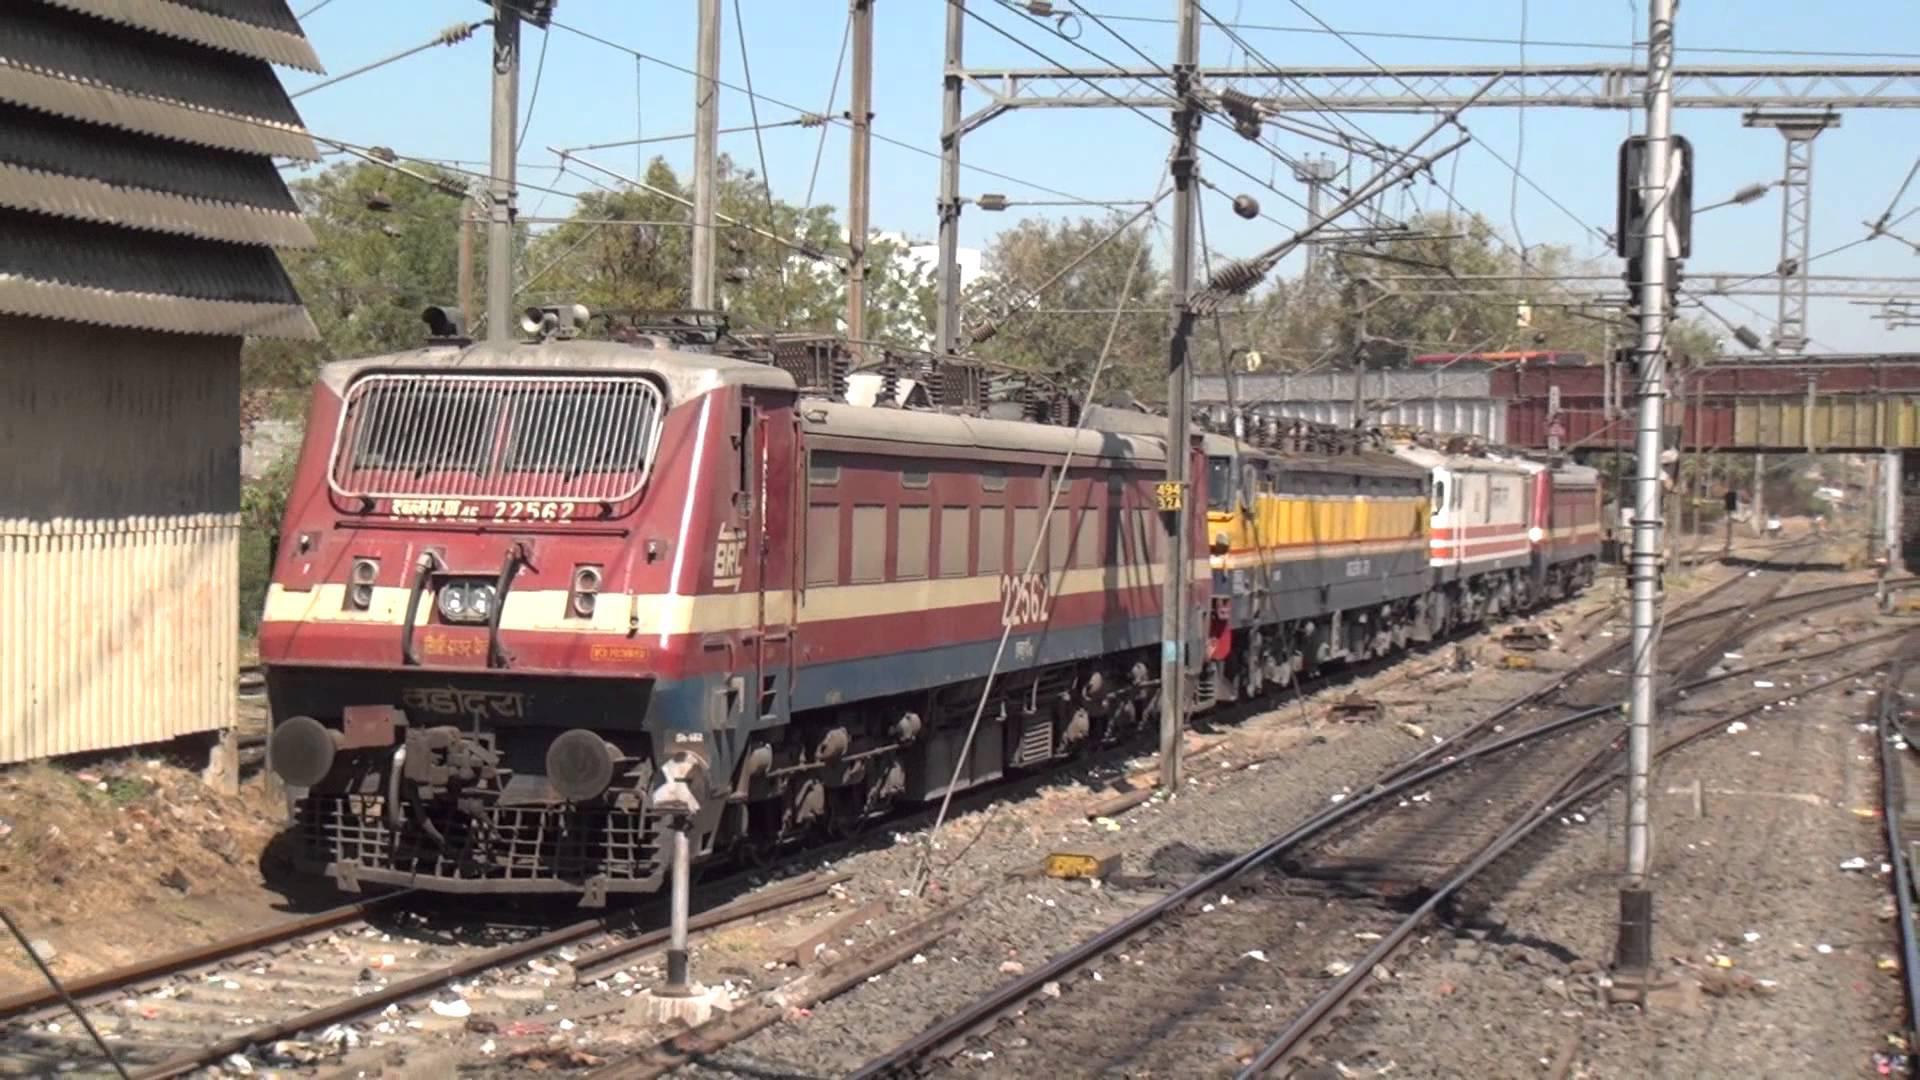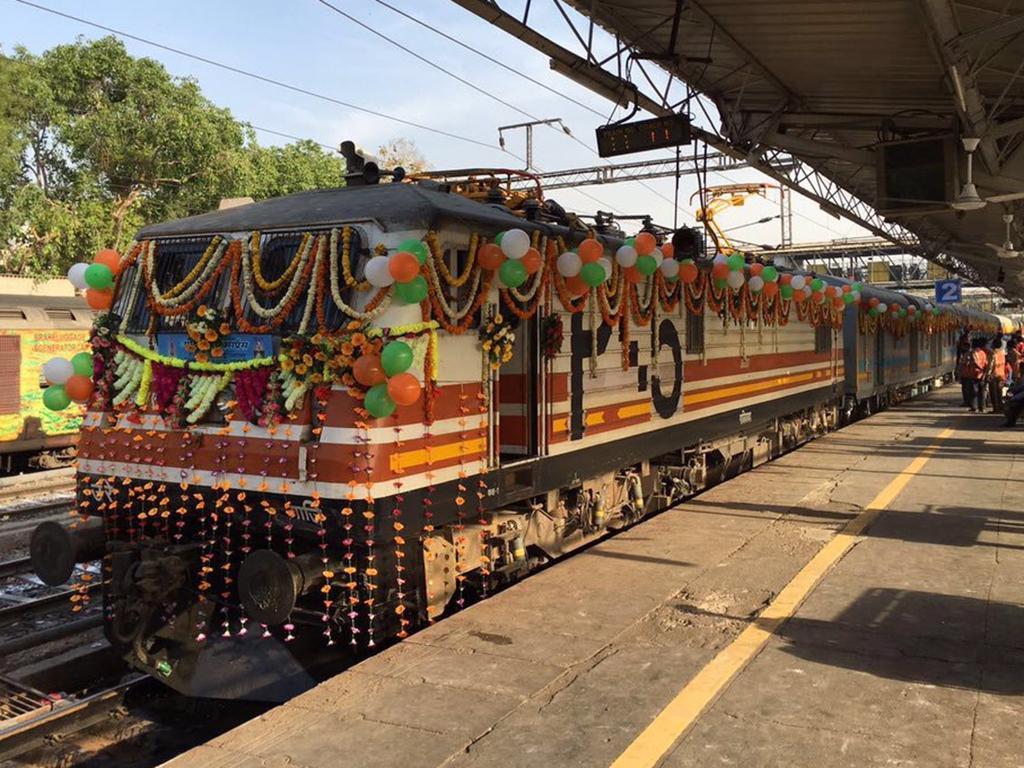The first image is the image on the left, the second image is the image on the right. For the images shown, is this caption "Two trains are angled so as to travel in the same direction when they move." true? Answer yes or no. Yes. The first image is the image on the left, the second image is the image on the right. For the images displayed, is the sentence "None of the trains have their headlights on and none of the them are decorated with balloons." factually correct? Answer yes or no. No. 